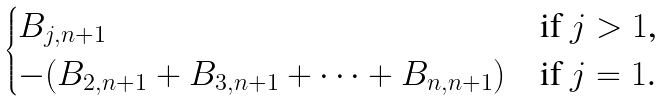<formula> <loc_0><loc_0><loc_500><loc_500>\begin{cases} B _ { j , n + 1 } & \text {if $j > 1$,} \\ - ( B _ { 2 , n + 1 } + B _ { 3 , n + 1 } + \cdots + B _ { n , n + 1 } ) & \text {if $j=1$.} \end{cases}</formula> 